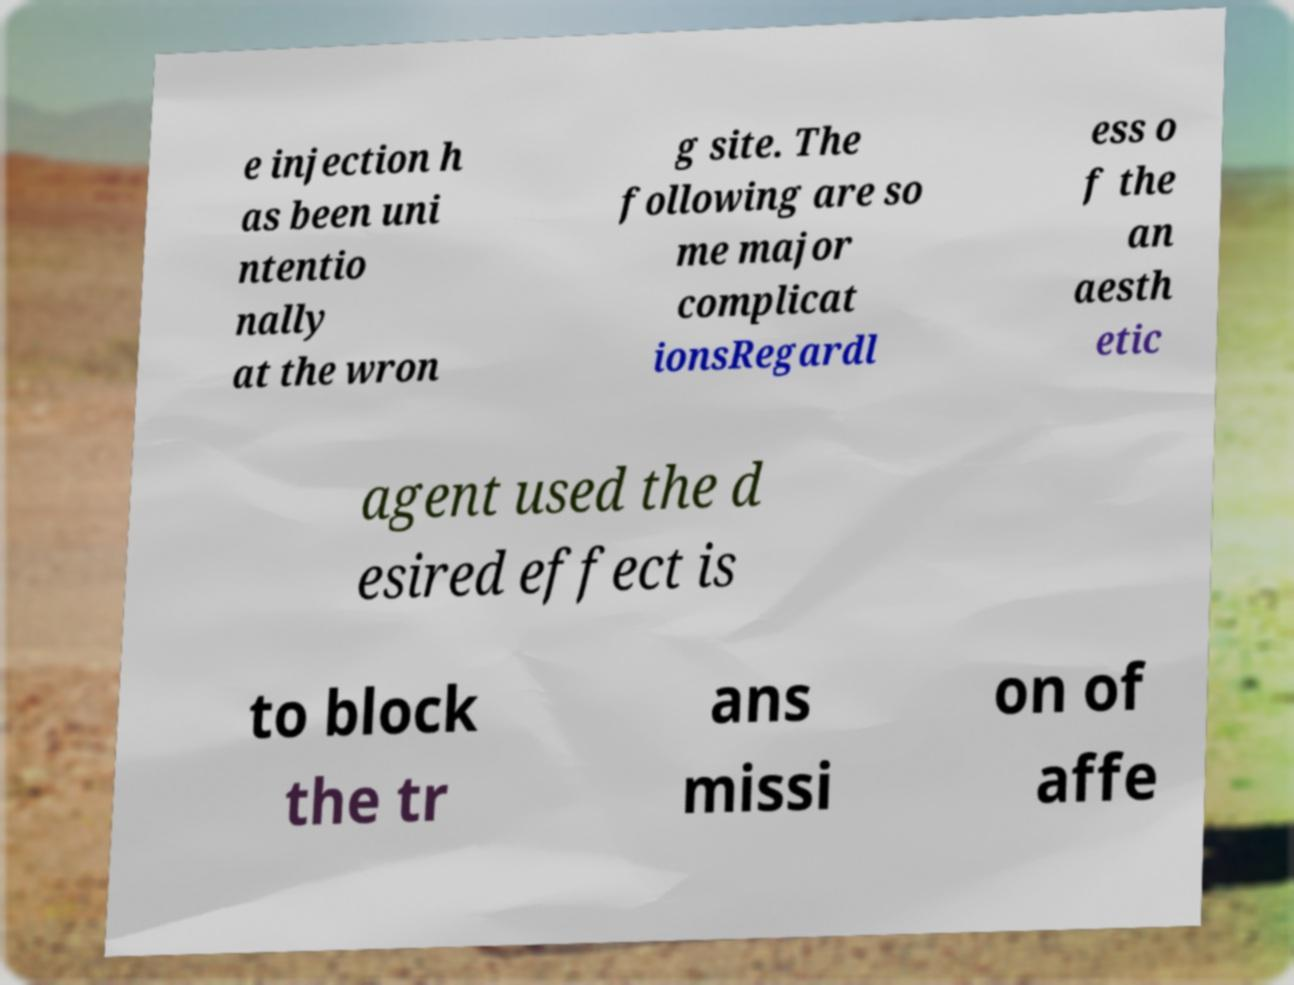Please identify and transcribe the text found in this image. e injection h as been uni ntentio nally at the wron g site. The following are so me major complicat ionsRegardl ess o f the an aesth etic agent used the d esired effect is to block the tr ans missi on of affe 